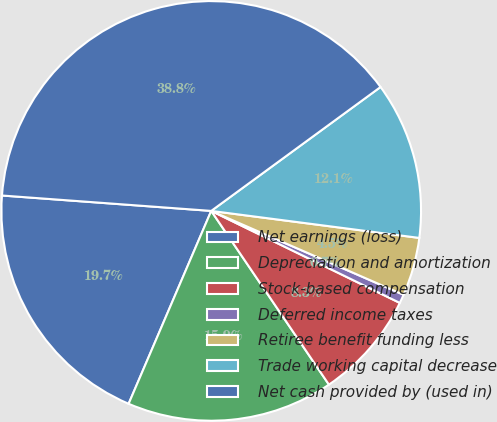Convert chart to OTSL. <chart><loc_0><loc_0><loc_500><loc_500><pie_chart><fcel>Net earnings (loss)<fcel>Depreciation and amortization<fcel>Stock-based compensation<fcel>Deferred income taxes<fcel>Retiree benefit funding less<fcel>Trade working capital decrease<fcel>Net cash provided by (used in)<nl><fcel>19.73%<fcel>15.92%<fcel>8.3%<fcel>0.68%<fcel>4.49%<fcel>12.11%<fcel>38.78%<nl></chart> 